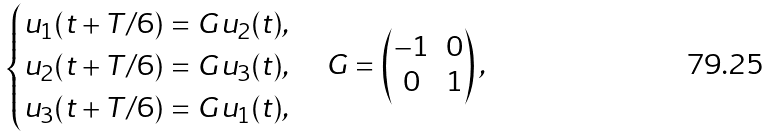Convert formula to latex. <formula><loc_0><loc_0><loc_500><loc_500>\begin{cases} u _ { 1 } ( t + T / 6 ) = G u _ { 2 } ( t ) , \\ u _ { 2 } ( t + T / 6 ) = G u _ { 3 } ( t ) , \\ u _ { 3 } ( t + T / 6 ) = G u _ { 1 } ( t ) , \end{cases} G = \begin{pmatrix} - 1 & 0 \\ 0 & 1 \\ \end{pmatrix} ,</formula> 